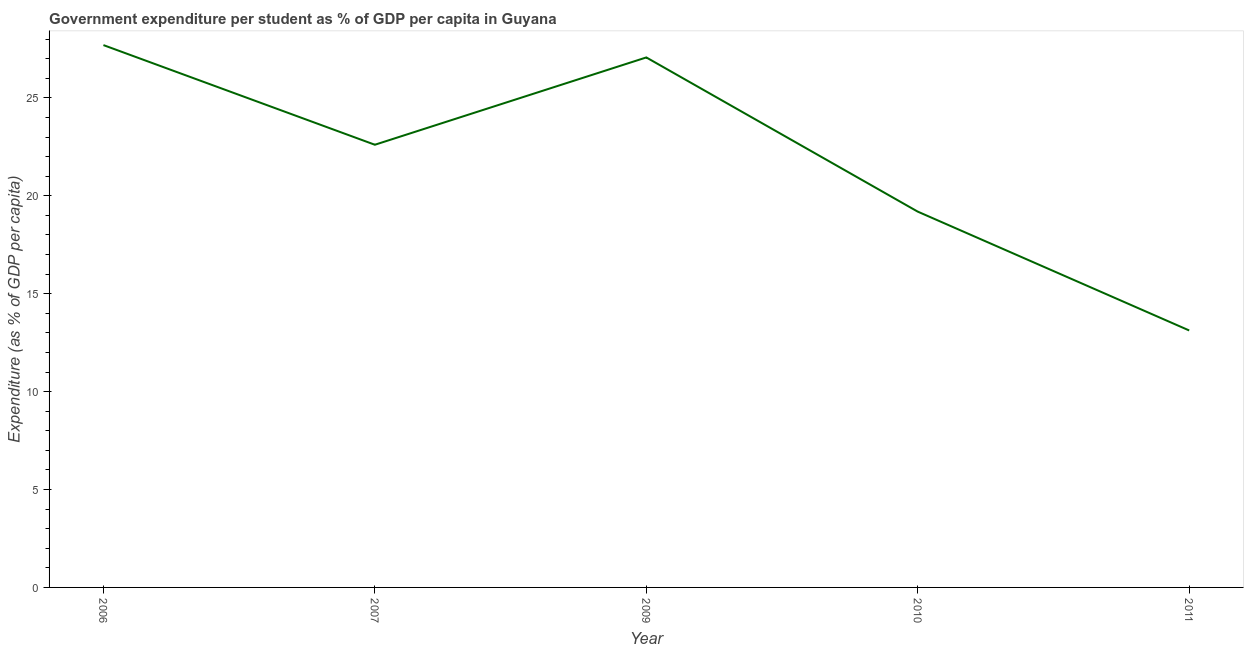What is the government expenditure per student in 2006?
Make the answer very short. 27.7. Across all years, what is the maximum government expenditure per student?
Keep it short and to the point. 27.7. Across all years, what is the minimum government expenditure per student?
Your answer should be compact. 13.12. In which year was the government expenditure per student maximum?
Give a very brief answer. 2006. In which year was the government expenditure per student minimum?
Provide a short and direct response. 2011. What is the sum of the government expenditure per student?
Provide a succinct answer. 109.68. What is the difference between the government expenditure per student in 2006 and 2010?
Your answer should be very brief. 8.5. What is the average government expenditure per student per year?
Your answer should be compact. 21.94. What is the median government expenditure per student?
Make the answer very short. 22.61. In how many years, is the government expenditure per student greater than 4 %?
Offer a very short reply. 5. What is the ratio of the government expenditure per student in 2009 to that in 2011?
Your answer should be very brief. 2.06. Is the government expenditure per student in 2007 less than that in 2009?
Make the answer very short. Yes. What is the difference between the highest and the second highest government expenditure per student?
Your answer should be compact. 0.63. Is the sum of the government expenditure per student in 2006 and 2009 greater than the maximum government expenditure per student across all years?
Give a very brief answer. Yes. What is the difference between the highest and the lowest government expenditure per student?
Your answer should be compact. 14.57. In how many years, is the government expenditure per student greater than the average government expenditure per student taken over all years?
Offer a very short reply. 3. How many lines are there?
Ensure brevity in your answer.  1. Are the values on the major ticks of Y-axis written in scientific E-notation?
Offer a terse response. No. Does the graph contain any zero values?
Your answer should be compact. No. Does the graph contain grids?
Keep it short and to the point. No. What is the title of the graph?
Your response must be concise. Government expenditure per student as % of GDP per capita in Guyana. What is the label or title of the Y-axis?
Make the answer very short. Expenditure (as % of GDP per capita). What is the Expenditure (as % of GDP per capita) in 2006?
Give a very brief answer. 27.7. What is the Expenditure (as % of GDP per capita) of 2007?
Your answer should be compact. 22.61. What is the Expenditure (as % of GDP per capita) in 2009?
Give a very brief answer. 27.06. What is the Expenditure (as % of GDP per capita) in 2010?
Offer a very short reply. 19.19. What is the Expenditure (as % of GDP per capita) in 2011?
Give a very brief answer. 13.12. What is the difference between the Expenditure (as % of GDP per capita) in 2006 and 2007?
Provide a short and direct response. 5.09. What is the difference between the Expenditure (as % of GDP per capita) in 2006 and 2009?
Provide a succinct answer. 0.63. What is the difference between the Expenditure (as % of GDP per capita) in 2006 and 2010?
Offer a very short reply. 8.5. What is the difference between the Expenditure (as % of GDP per capita) in 2006 and 2011?
Your response must be concise. 14.57. What is the difference between the Expenditure (as % of GDP per capita) in 2007 and 2009?
Provide a short and direct response. -4.46. What is the difference between the Expenditure (as % of GDP per capita) in 2007 and 2010?
Provide a succinct answer. 3.42. What is the difference between the Expenditure (as % of GDP per capita) in 2007 and 2011?
Ensure brevity in your answer.  9.48. What is the difference between the Expenditure (as % of GDP per capita) in 2009 and 2010?
Offer a terse response. 7.87. What is the difference between the Expenditure (as % of GDP per capita) in 2009 and 2011?
Make the answer very short. 13.94. What is the difference between the Expenditure (as % of GDP per capita) in 2010 and 2011?
Keep it short and to the point. 6.07. What is the ratio of the Expenditure (as % of GDP per capita) in 2006 to that in 2007?
Make the answer very short. 1.23. What is the ratio of the Expenditure (as % of GDP per capita) in 2006 to that in 2009?
Your answer should be very brief. 1.02. What is the ratio of the Expenditure (as % of GDP per capita) in 2006 to that in 2010?
Provide a short and direct response. 1.44. What is the ratio of the Expenditure (as % of GDP per capita) in 2006 to that in 2011?
Your answer should be very brief. 2.11. What is the ratio of the Expenditure (as % of GDP per capita) in 2007 to that in 2009?
Give a very brief answer. 0.83. What is the ratio of the Expenditure (as % of GDP per capita) in 2007 to that in 2010?
Offer a very short reply. 1.18. What is the ratio of the Expenditure (as % of GDP per capita) in 2007 to that in 2011?
Provide a succinct answer. 1.72. What is the ratio of the Expenditure (as % of GDP per capita) in 2009 to that in 2010?
Make the answer very short. 1.41. What is the ratio of the Expenditure (as % of GDP per capita) in 2009 to that in 2011?
Your answer should be compact. 2.06. What is the ratio of the Expenditure (as % of GDP per capita) in 2010 to that in 2011?
Give a very brief answer. 1.46. 